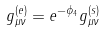<formula> <loc_0><loc_0><loc_500><loc_500>g ^ { ( e ) } _ { \mu \nu } = e ^ { - \phi _ { 4 } } g ^ { ( s ) } _ { \mu \nu }</formula> 